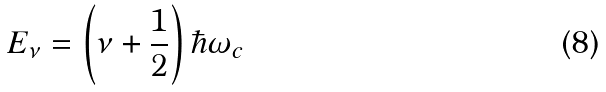<formula> <loc_0><loc_0><loc_500><loc_500>E _ { \nu } = \left ( \nu + \frac { 1 } { 2 } \right ) \hbar { \omega } _ { c }</formula> 